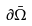Convert formula to latex. <formula><loc_0><loc_0><loc_500><loc_500>\partial { \bar { \Omega } }</formula> 